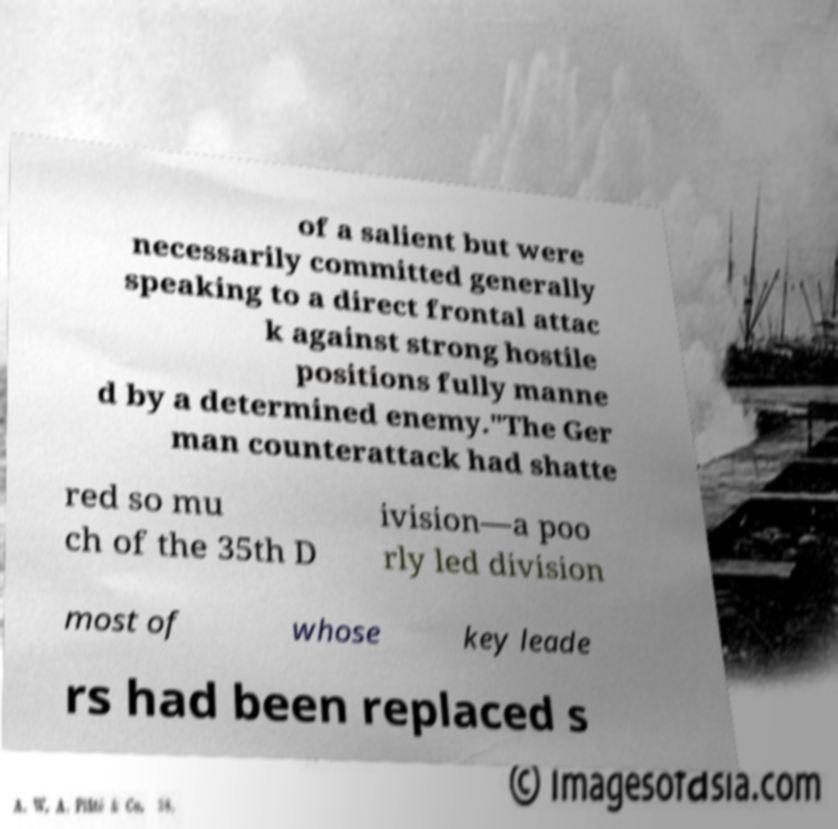What messages or text are displayed in this image? I need them in a readable, typed format. of a salient but were necessarily committed generally speaking to a direct frontal attac k against strong hostile positions fully manne d by a determined enemy."The Ger man counterattack had shatte red so mu ch of the 35th D ivision—a poo rly led division most of whose key leade rs had been replaced s 